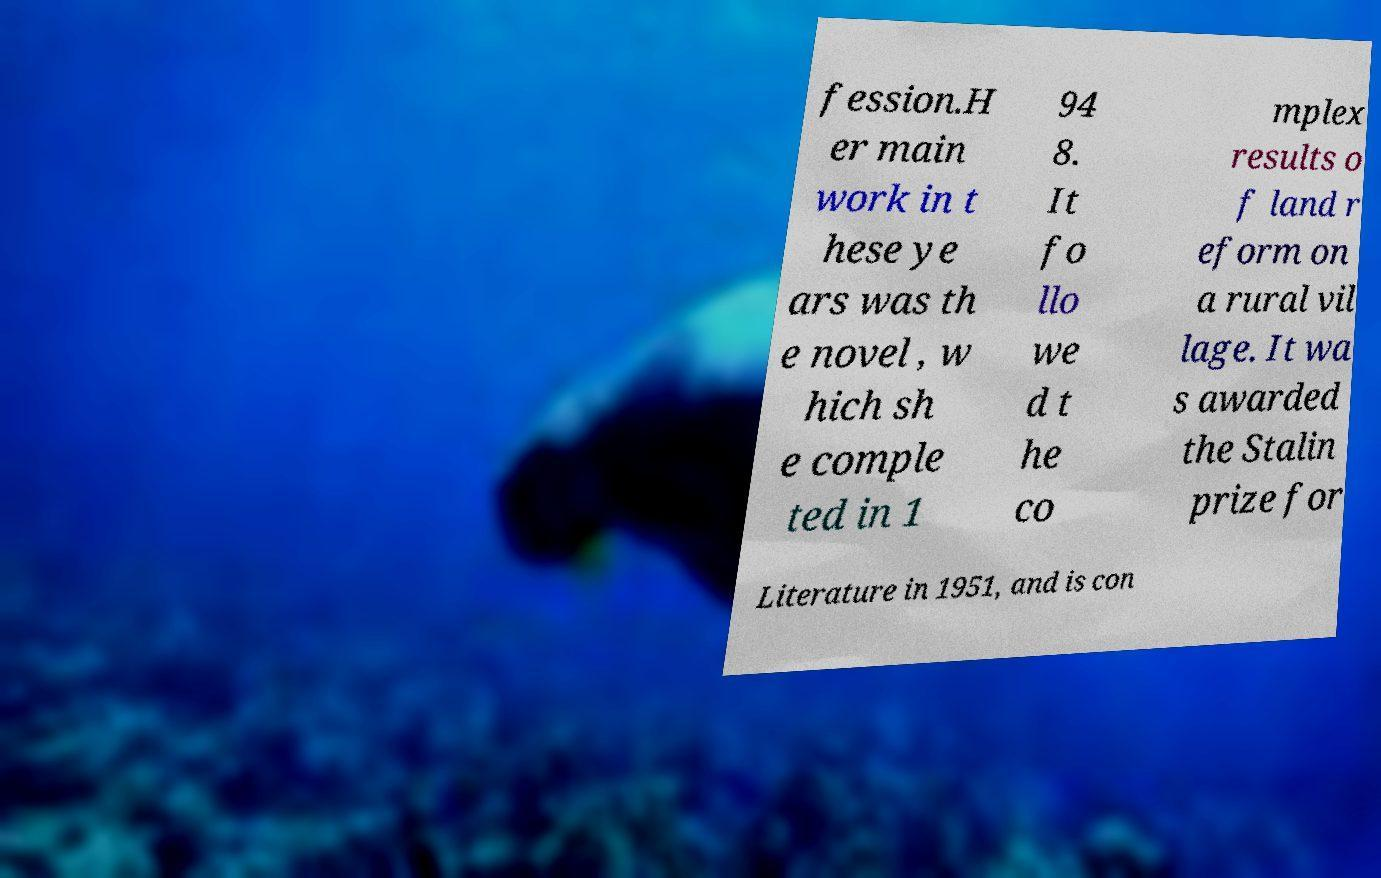There's text embedded in this image that I need extracted. Can you transcribe it verbatim? fession.H er main work in t hese ye ars was th e novel , w hich sh e comple ted in 1 94 8. It fo llo we d t he co mplex results o f land r eform on a rural vil lage. It wa s awarded the Stalin prize for Literature in 1951, and is con 